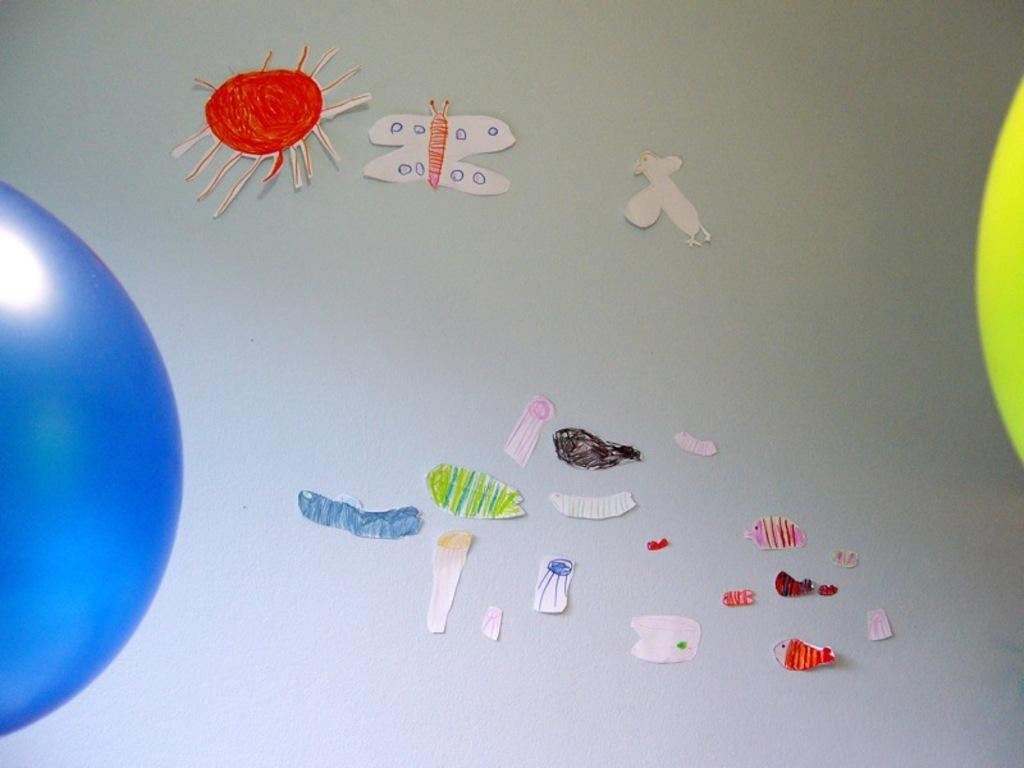What type of crafts can be seen in the image? There are paper crafts in the image. What can be seen in the background of the image? The background of the image features a plane. How many apples are hanging from the plane in the image? There are no apples present in the image; it features paper crafts and a plane in the background. 